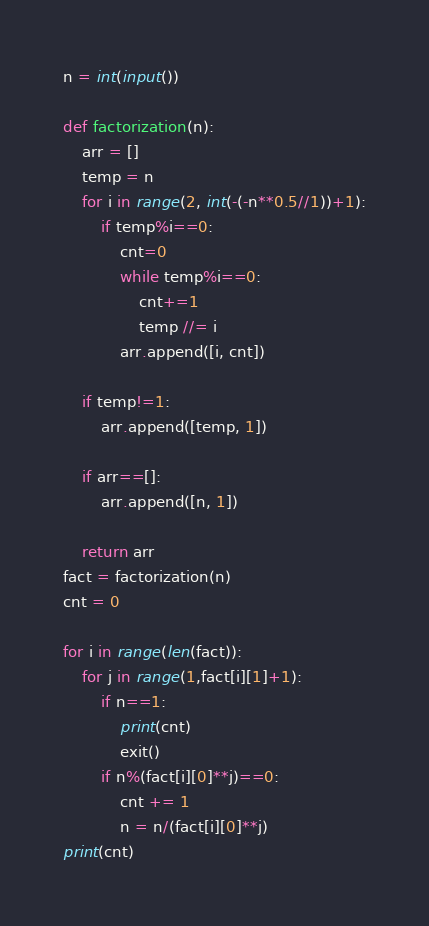<code> <loc_0><loc_0><loc_500><loc_500><_Python_>n = int(input())

def factorization(n):
    arr = []
    temp = n
    for i in range(2, int(-(-n**0.5//1))+1):
        if temp%i==0:
            cnt=0
            while temp%i==0:
                cnt+=1
                temp //= i
            arr.append([i, cnt])

    if temp!=1:
        arr.append([temp, 1])

    if arr==[]:
        arr.append([n, 1])

    return arr
fact = factorization(n)
cnt = 0

for i in range(len(fact)):
    for j in range(1,fact[i][1]+1):
        if n==1:
            print(cnt)
            exit()
        if n%(fact[i][0]**j)==0:
            cnt += 1
            n = n/(fact[i][0]**j)
print(cnt)


</code> 